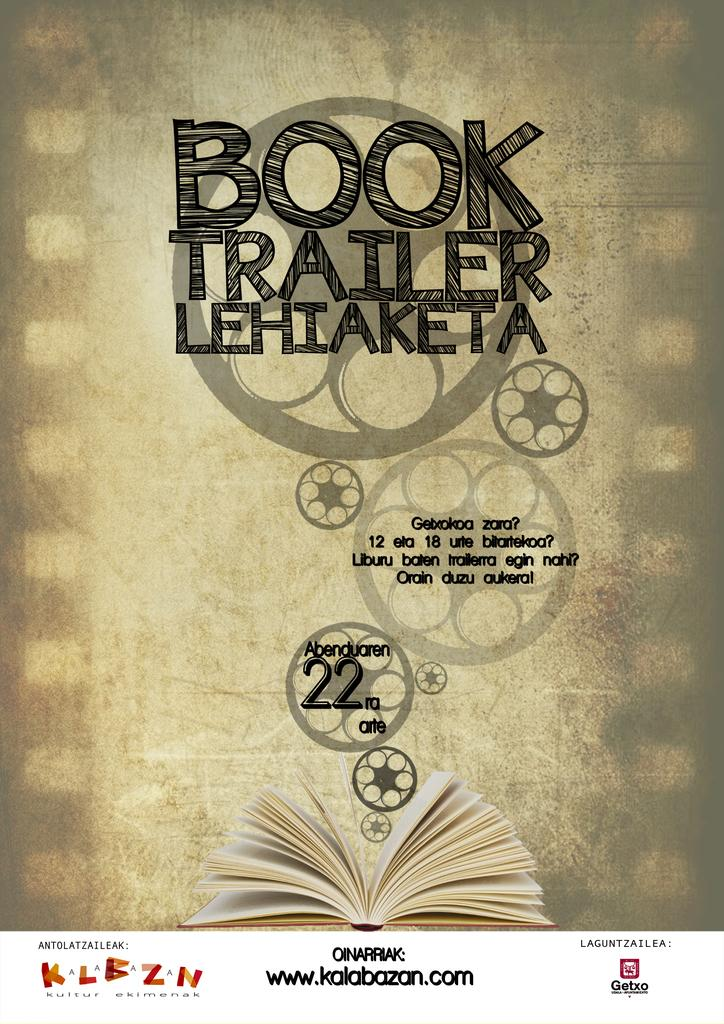<image>
Offer a succinct explanation of the picture presented. Promotion for how to make a Book Trailer, presented by kalabazan.com. 